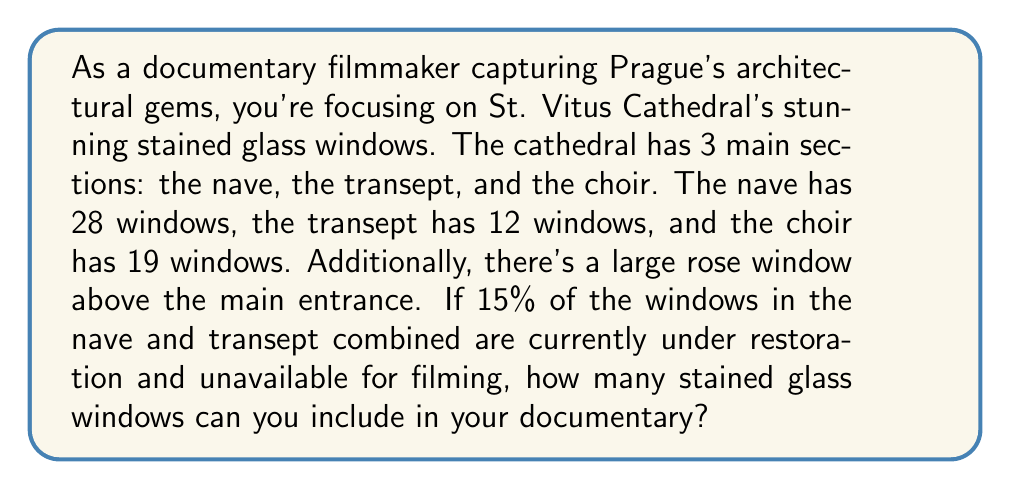Give your solution to this math problem. Let's break this down step-by-step:

1. Calculate the total number of windows in the cathedral:
   $$ \text{Total windows} = \text{Nave} + \text{Transept} + \text{Choir} + \text{Rose window} $$
   $$ \text{Total windows} = 28 + 12 + 19 + 1 = 60 $$

2. Calculate the number of windows in the nave and transept combined:
   $$ \text{Nave and Transept} = 28 + 12 = 40 $$

3. Calculate the number of windows under restoration:
   $$ \text{Under restoration} = 15\% \text{ of } 40 = 0.15 \times 40 = 6 $$

4. Calculate the number of available windows:
   $$ \text{Available windows} = \text{Total windows} - \text{Under restoration} $$
   $$ \text{Available windows} = 60 - 6 = 54 $$

Therefore, you can include 54 stained glass windows in your documentary.
Answer: 54 stained glass windows 